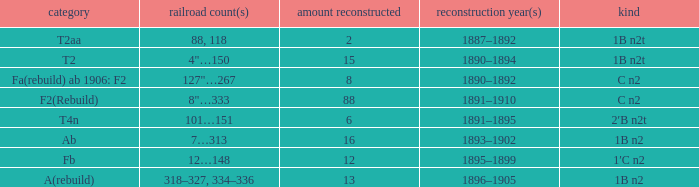What is the total of quantity rebuilt if the type is 1B N2T and the railway number is 88, 118? 1.0. 